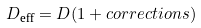Convert formula to latex. <formula><loc_0><loc_0><loc_500><loc_500>D _ { \text {eff} } = D ( 1 + c o r r e c t i o n s )</formula> 